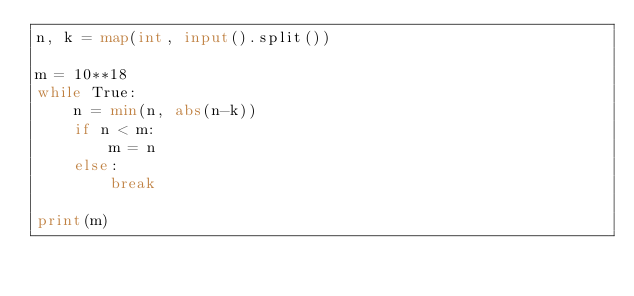Convert code to text. <code><loc_0><loc_0><loc_500><loc_500><_Python_>n, k = map(int, input().split())

m = 10**18
while True:
    n = min(n, abs(n-k)) 
    if n < m:
        m = n
    else:
        break

print(m)</code> 